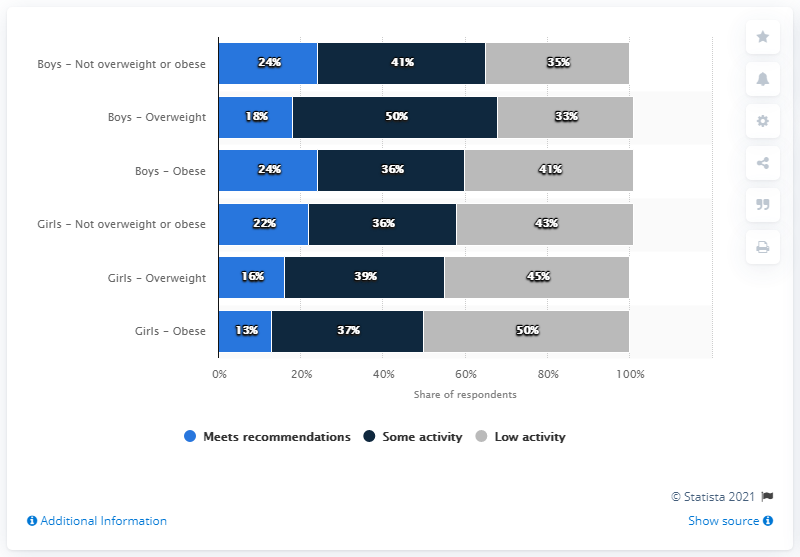Indicate a few pertinent items in this graphic. In this study, the researchers found that only a small percentage of obese boys and a slightly larger percentage of obese girls met the recommended guidelines for physical activity, which included at least 60 minutes of exercise per day. Specifically, 13% of obese girls met these guidelines. 